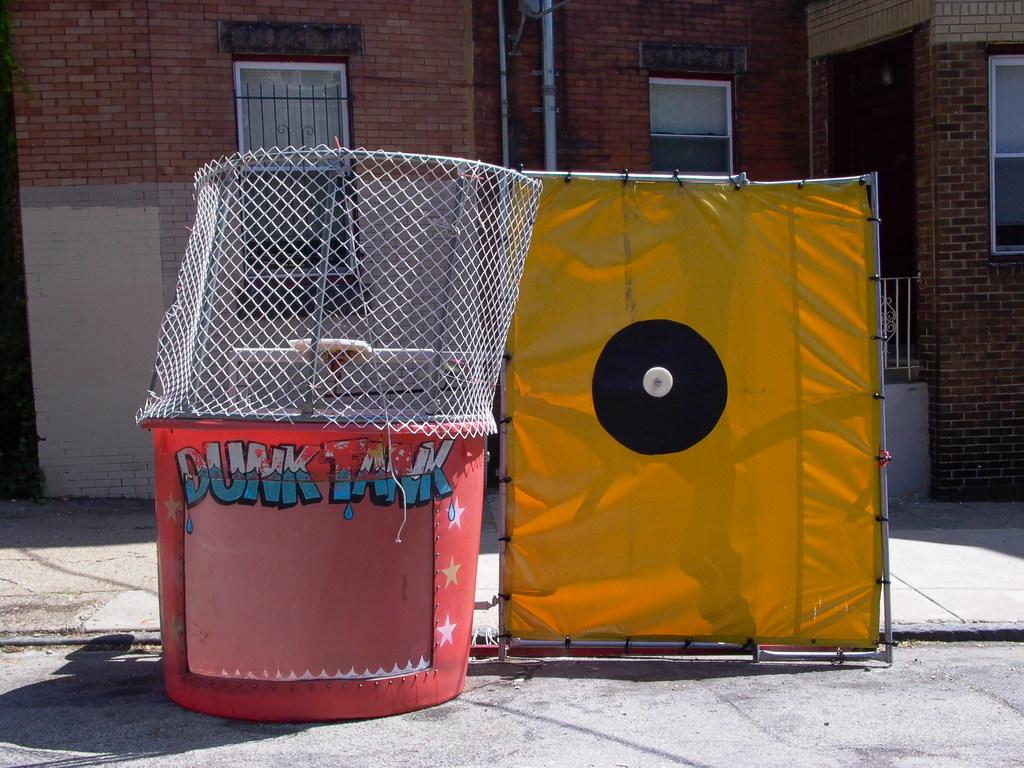Is there grafitti in the image?
Your answer should be compact. Yes. 